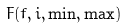<formula> <loc_0><loc_0><loc_500><loc_500>F ( f , i , \min , \max )</formula> 